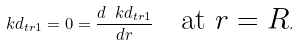<formula> <loc_0><loc_0><loc_500><loc_500>\ k d _ { t r 1 } = 0 = \frac { d \ k d _ { t r 1 } } { d r } \quad \text {at $r=R$} .</formula> 